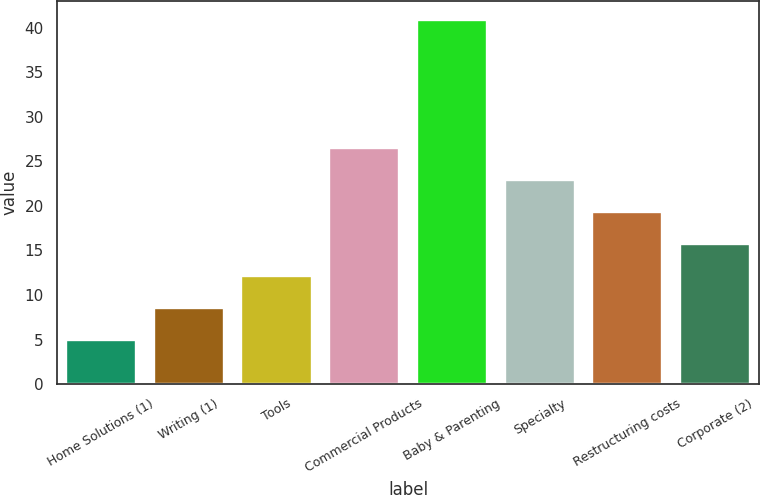<chart> <loc_0><loc_0><loc_500><loc_500><bar_chart><fcel>Home Solutions (1)<fcel>Writing (1)<fcel>Tools<fcel>Commercial Products<fcel>Baby & Parenting<fcel>Specialty<fcel>Restructuring costs<fcel>Corporate (2)<nl><fcel>5<fcel>8.59<fcel>12.18<fcel>26.54<fcel>40.9<fcel>22.95<fcel>19.36<fcel>15.77<nl></chart> 